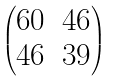Convert formula to latex. <formula><loc_0><loc_0><loc_500><loc_500>\begin{pmatrix} 6 0 & 4 6 \\ 4 6 & 3 9 \end{pmatrix}</formula> 